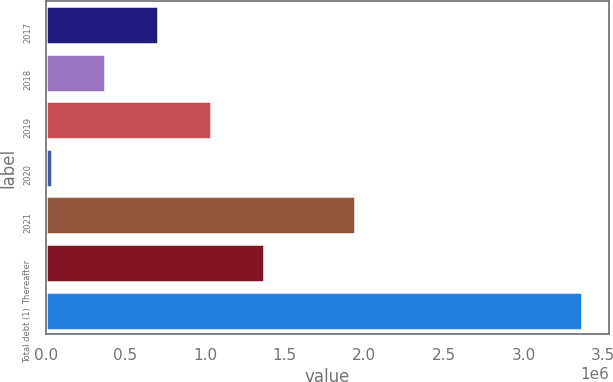Convert chart to OTSL. <chart><loc_0><loc_0><loc_500><loc_500><bar_chart><fcel>2017<fcel>2018<fcel>2019<fcel>2020<fcel>2021<fcel>Thereafter<fcel>Total debt (1)<nl><fcel>704339<fcel>371670<fcel>1.03701e+06<fcel>39002<fcel>1.94268e+06<fcel>1.36968e+06<fcel>3.36569e+06<nl></chart> 